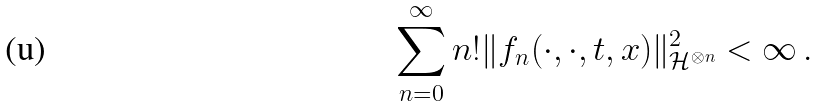<formula> <loc_0><loc_0><loc_500><loc_500>\sum _ { n = 0 } ^ { \infty } n ! \| f _ { n } ( \cdot , \cdot , t , x ) \| ^ { 2 } _ { \mathcal { H } ^ { \otimes n } } < \infty \, .</formula> 